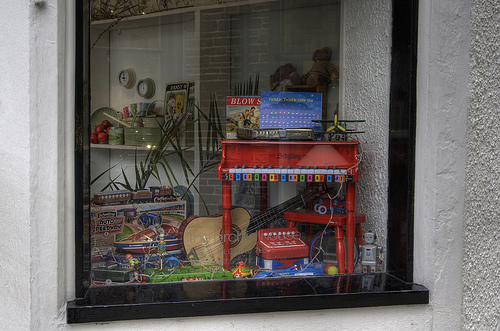<image>
Is the guitar in the shelf? Yes. The guitar is contained within or inside the shelf, showing a containment relationship. 